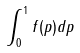<formula> <loc_0><loc_0><loc_500><loc_500>\int _ { 0 } ^ { 1 } f ( p ) d p</formula> 